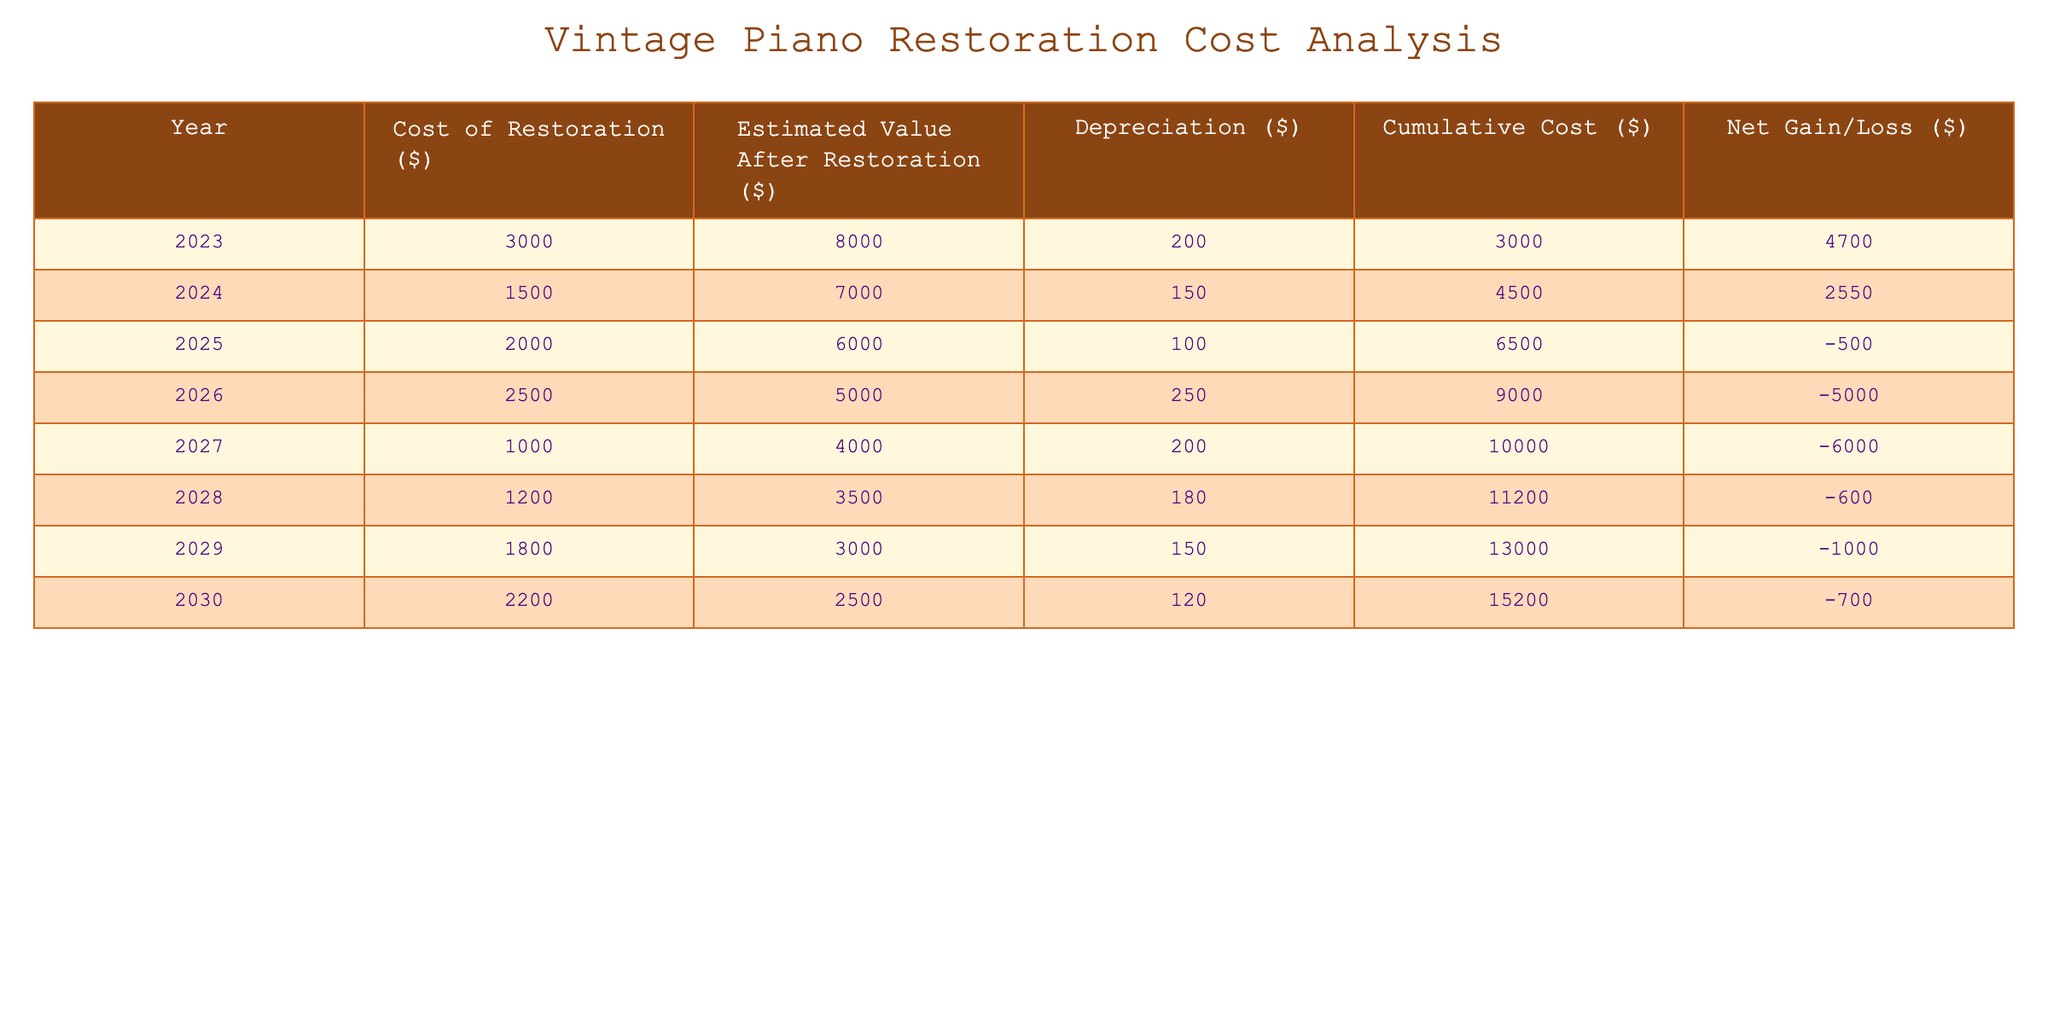What is the cost of restoration in the year 2025? The table lists the cost of restoration for each year, and according to the row for 2025, the cost is $2000.
Answer: 2000 What is the estimated value of the piano after restoration in 2023? The estimated value after restoration for the year 2023 can be found in the corresponding row, which shows $8000.
Answer: 8000 What is the cumulative cost of restoration by 2026? Cumulative cost for each year is shown in the table, and for 2026, the cumulative cost is $9000.
Answer: 9000 What was the net gain/loss by 2028? The net gain/loss for each year is listed, and for 2028 it is -600, indicating a loss.
Answer: -600 Is the estimated value after restoration decreasing over the years? To determine this, we can look at the estimated values: $8000 in 2023, $7000 in 2024, $6000 in 2025, $5000 in 2026, $4000 in 2027, $3500 in 2028, and $3000 in 2029. It is indeed decreasing each year.
Answer: Yes What is the average cost of restoration across all years? We first sum the costs for all years: $3000 + $1500 + $2000 + $2500 + $1000 + $1200 + $1800 + $2200 = $13200. There are 8 years, so the average is $13200 / 8 = $1650.
Answer: 1650 In which year was the highest cost of restoration? By inspecting the cost of restoration for each year, the highest cost is $3000 in 2023.
Answer: 2023 What is the total net gain/loss by 2030? The net gain/loss for each year can be summed to get the total up to 2030: 4700 + 2550 - 500 - 5000 - 600 - 1000 - 700 = -4200.
Answer: -4200 Was the cost of restoration more than $2000 in 2024? Looking at the table, it shows the cost of restoration for 2024 is $1500, which is less than $2000.
Answer: No 